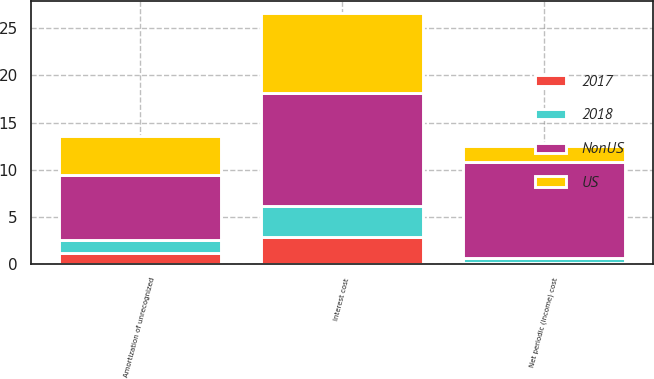<chart> <loc_0><loc_0><loc_500><loc_500><stacked_bar_chart><ecel><fcel>Interest cost<fcel>Amortization of unrecognized<fcel>Net periodic (income) cost<nl><fcel>US<fcel>8.5<fcel>4.2<fcel>1.7<nl><fcel>NonUS<fcel>12<fcel>6.9<fcel>10.2<nl><fcel>2017<fcel>2.9<fcel>1.2<fcel>0.1<nl><fcel>2018<fcel>3.2<fcel>1.3<fcel>0.5<nl></chart> 